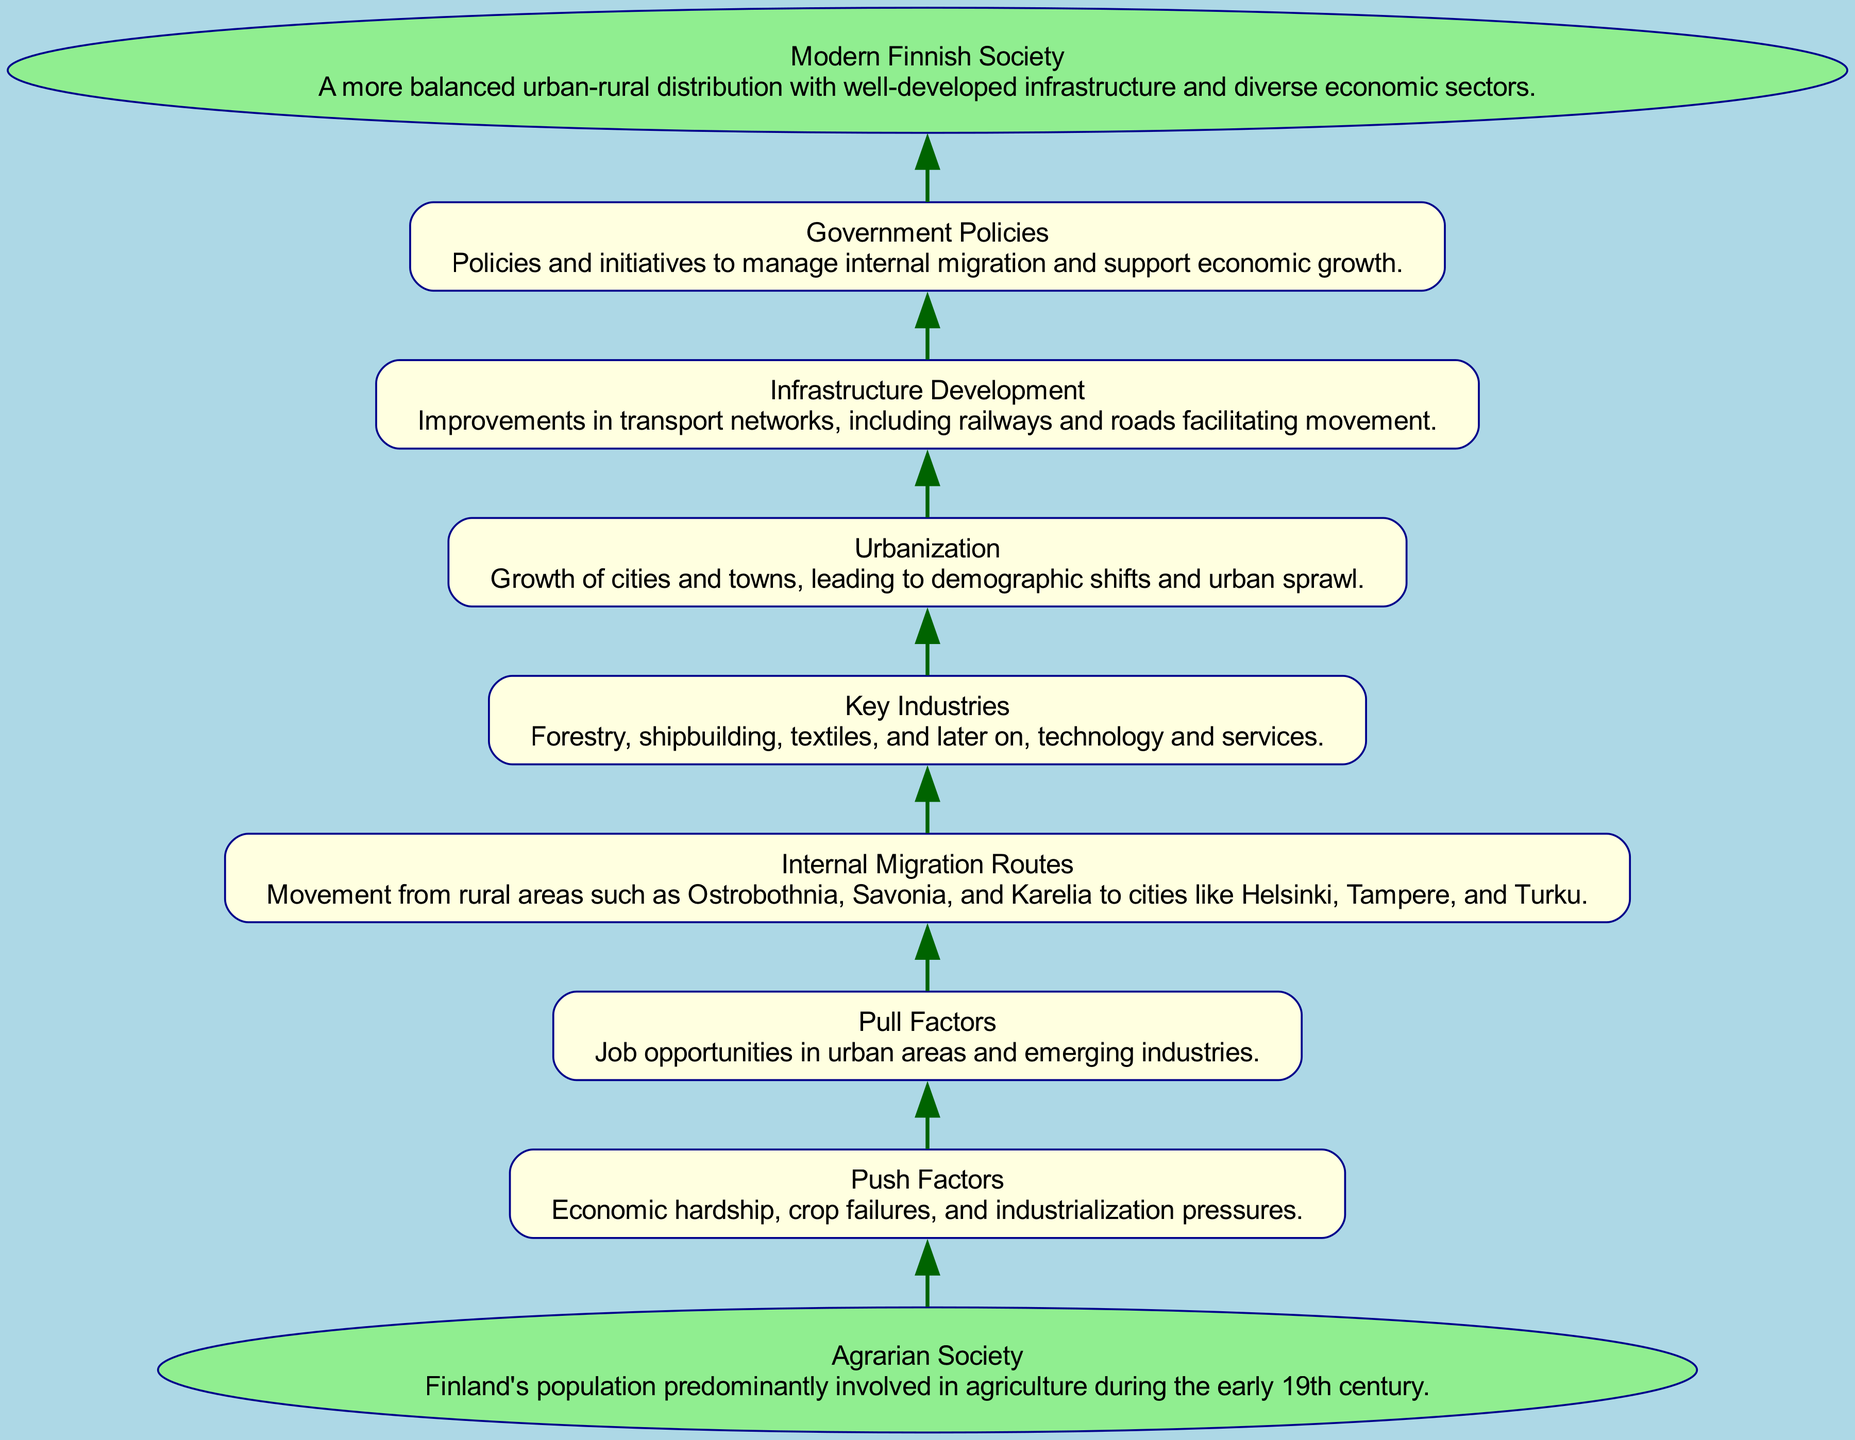What is the starting point of the migration pattern? The starting point in the diagram is labeled as "Agrarian Society," which describes the context of Finland's population being primarily involved in agriculture during the early 19th century.
Answer: Agrarian Society What factor led to internal migration? The factor labeled under "Push Factors" indicates that economic hardship, crop failures, and industrialization pressures prompted migration from rural to urban areas.
Answer: Push Factors How many key industries are mentioned in the diagram? The diagram lists "Key Industries," specifically mentioning forestry, shipbuilding, textiles, and technology and services. This makes a total of four key industries cited.
Answer: Four What does "Urbanization" lead to according to the flow of the diagram? The "Urbanization" step indicates that there is a growth of cities and towns leading to demographic shifts and urban sprawl, which directly follows it in the sequence of steps.
Answer: Demographic shifts and urban sprawl Which step comes after "Internal Migration Routes"? The step that follows "Internal Migration Routes" in the progression of the diagram is labeled "Key Industries," indicating that the migration was influenced by recognized key sectors in the economy.
Answer: Key Industries How does "Infrastructure Development" contribute to migration? "Infrastructure Development" provides improvements in transport networks, which facilitates movement and supports the migration process, linking the step to both urbanization and government policies.
Answer: Facilitates movement What is the end outcome of migration patterns within Finland? The final outcome node, labeled "Modern Finnish Society," represents a balanced urban-rural distribution, indicating a transformation of the society due to the migration patterns discussed.
Answer: Modern Finnish Society How do "Government Policies" relate to migration patterns? Government Policies are placed in the flow to show that these initiatives were designed to manage internal migration, supporting economic growth and connectivity, directly influencing the pattern discussed in previous steps.
Answer: Manage internal migration What transition occurs between "Push Factors" and "Pull Factors"? The transition signifies a shift from the challenges experienced in rural areas that push individuals to migrate, to the opportunities found in urban locales that pull them towards new jobs and industries.
Answer: Challenges to opportunities 